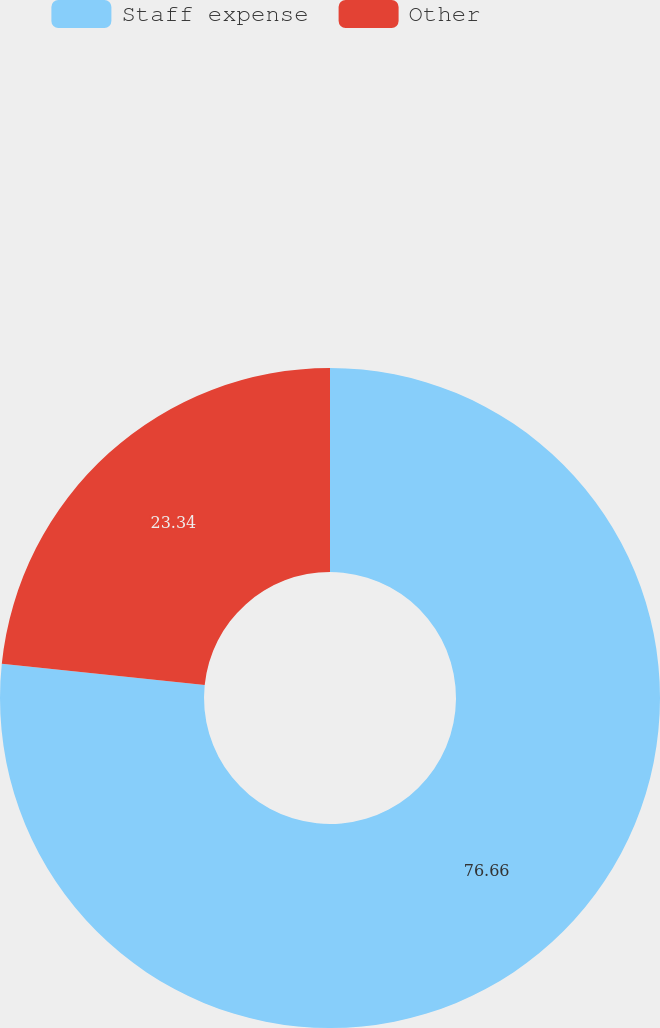Convert chart to OTSL. <chart><loc_0><loc_0><loc_500><loc_500><pie_chart><fcel>Staff expense<fcel>Other<nl><fcel>76.66%<fcel>23.34%<nl></chart> 